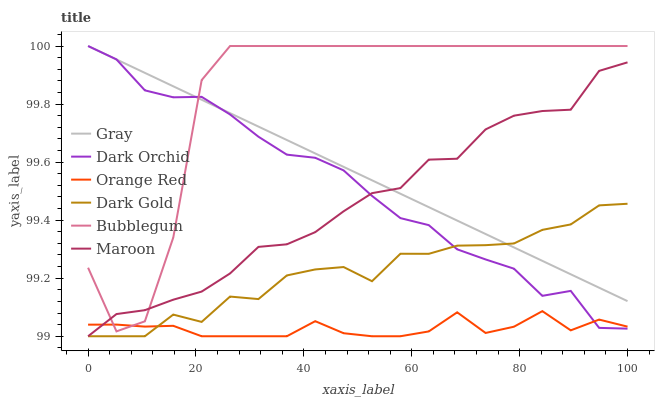Does Dark Gold have the minimum area under the curve?
Answer yes or no. No. Does Dark Gold have the maximum area under the curve?
Answer yes or no. No. Is Dark Gold the smoothest?
Answer yes or no. No. Is Dark Gold the roughest?
Answer yes or no. No. Does Dark Orchid have the lowest value?
Answer yes or no. No. Does Dark Gold have the highest value?
Answer yes or no. No. Is Dark Gold less than Bubblegum?
Answer yes or no. Yes. Is Bubblegum greater than Dark Gold?
Answer yes or no. Yes. Does Dark Gold intersect Bubblegum?
Answer yes or no. No. 